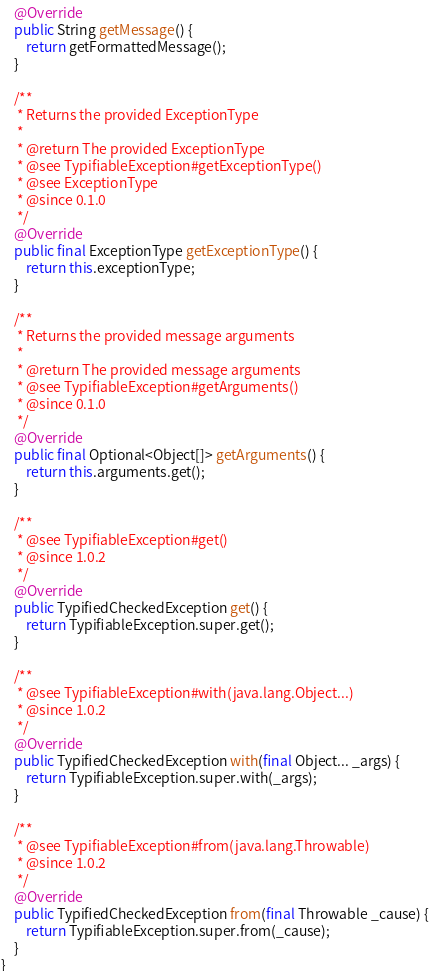Convert code to text. <code><loc_0><loc_0><loc_500><loc_500><_Java_>	@Override
	public String getMessage() {
		return getFormattedMessage();
	}

	/**
	 * Returns the provided ExceptionType
	 *
	 * @return The provided ExceptionType
	 * @see TypifiableException#getExceptionType()
	 * @see ExceptionType
	 * @since 0.1.0
	 */
	@Override
	public final ExceptionType getExceptionType() {
		return this.exceptionType;
	}

	/**
	 * Returns the provided message arguments
	 *
	 * @return The provided message arguments
	 * @see TypifiableException#getArguments()
	 * @since 0.1.0
	 */
	@Override
	public final Optional<Object[]> getArguments() {
		return this.arguments.get();
	}

	/**
	 * @see TypifiableException#get() 
	 * @since 1.0.2
	 */
	@Override
	public TypifiedCheckedException get() {
		return TypifiableException.super.get(); 
	}

	/**
	 * @see TypifiableException#with(java.lang.Object...)
	 * @since 1.0.2
	 */
	@Override
	public TypifiedCheckedException with(final Object... _args) {
		return TypifiableException.super.with(_args);
	}

	/**
	 * @see TypifiableException#from(java.lang.Throwable) 
	 * @since 1.0.2
	 */
	@Override
	public TypifiedCheckedException from(final Throwable _cause) {
		return TypifiableException.super.from(_cause);
	}
}
</code> 